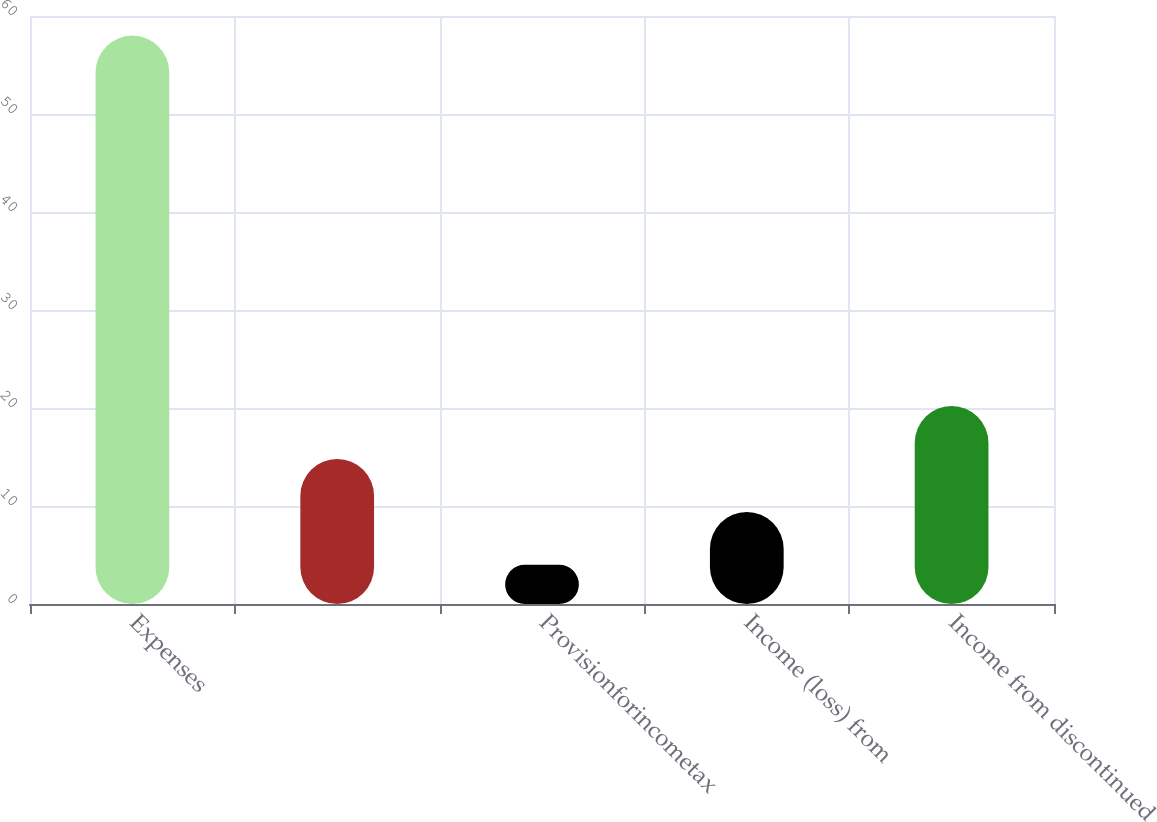<chart> <loc_0><loc_0><loc_500><loc_500><bar_chart><fcel>Expenses<fcel>Unnamed: 1<fcel>Provisionforincometax<fcel>Income (loss) from<fcel>Income from discontinued<nl><fcel>58<fcel>14.8<fcel>4<fcel>9.4<fcel>20.2<nl></chart> 